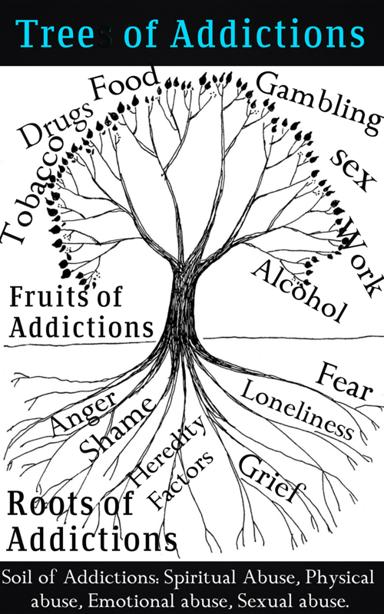Can you explain how the 'roots' and 'soil' of the Tree of Addictions interact? Certainly. In the context of the Tree of Addictions, the 'roots' represent the underlying factors such as hereditary tendencies that may predispose someone to addictive behaviors. Meanwhile, the 'soil' symbolizes the environmental factors and past traumas, like various forms of abuse, which can influence the development and perpetuation of addiction. The roots draw sustenance from the soil, implying that the genetic predispositions are fueled or triggered by the abusive experiences. This interaction suggests that both the inherent vulnerability to addiction and the external circumstances are intrinsically linked, each profoundly affecting the growth and the strength of the addictive patterns. Addressing both the genetic factors and the environmental factors is crucial in the process of recovery. 